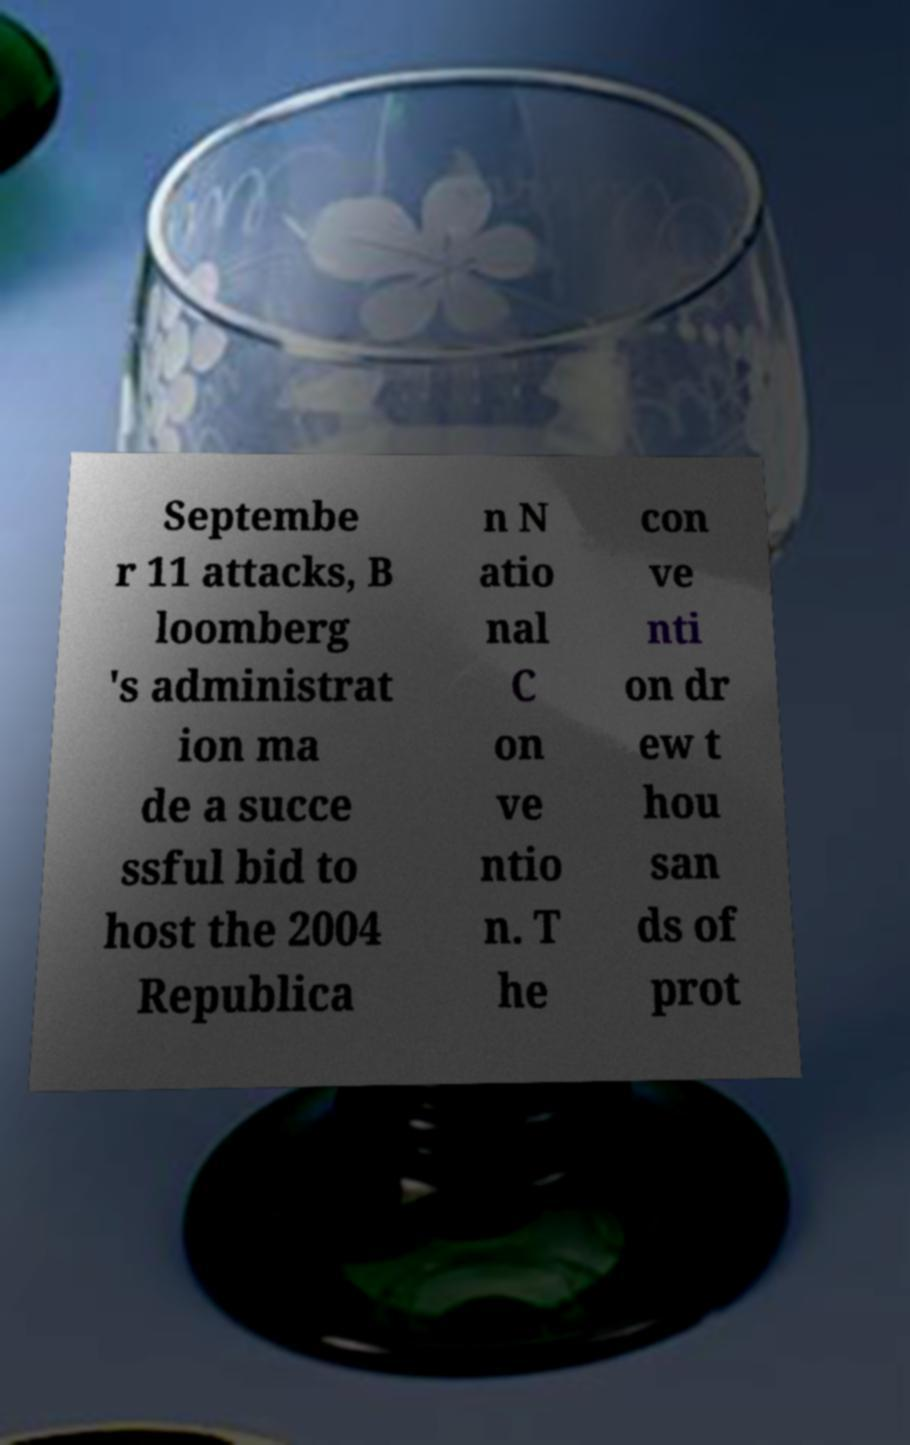For documentation purposes, I need the text within this image transcribed. Could you provide that? Septembe r 11 attacks, B loomberg 's administrat ion ma de a succe ssful bid to host the 2004 Republica n N atio nal C on ve ntio n. T he con ve nti on dr ew t hou san ds of prot 